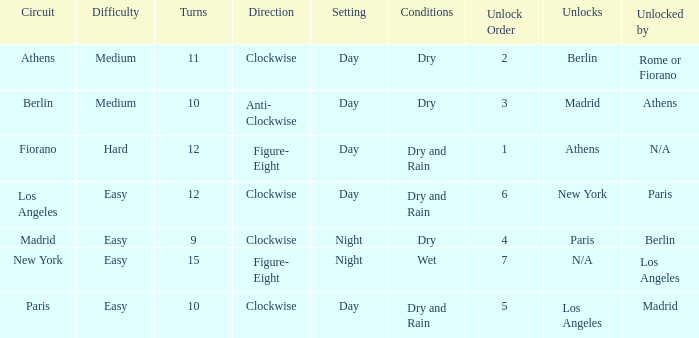What is the lowest unlock order for the athens circuit? 2.0. 